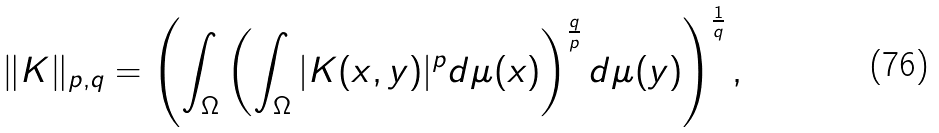<formula> <loc_0><loc_0><loc_500><loc_500>\| K \| _ { p , q } = \left ( \int _ { \Omega } \left ( \int _ { \Omega } | K ( x , y ) | ^ { p } d \mu ( x ) \right ) ^ { \frac { q } { p } } d \mu ( y ) \right ) ^ { \frac { 1 } { q } } ,</formula> 